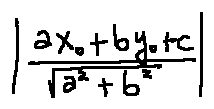<formula> <loc_0><loc_0><loc_500><loc_500>| \frac { a x _ { 0 } + b y _ { 0 } + c } { \sqrt { a ^ { 2 } + b ^ { 2 } } } |</formula> 